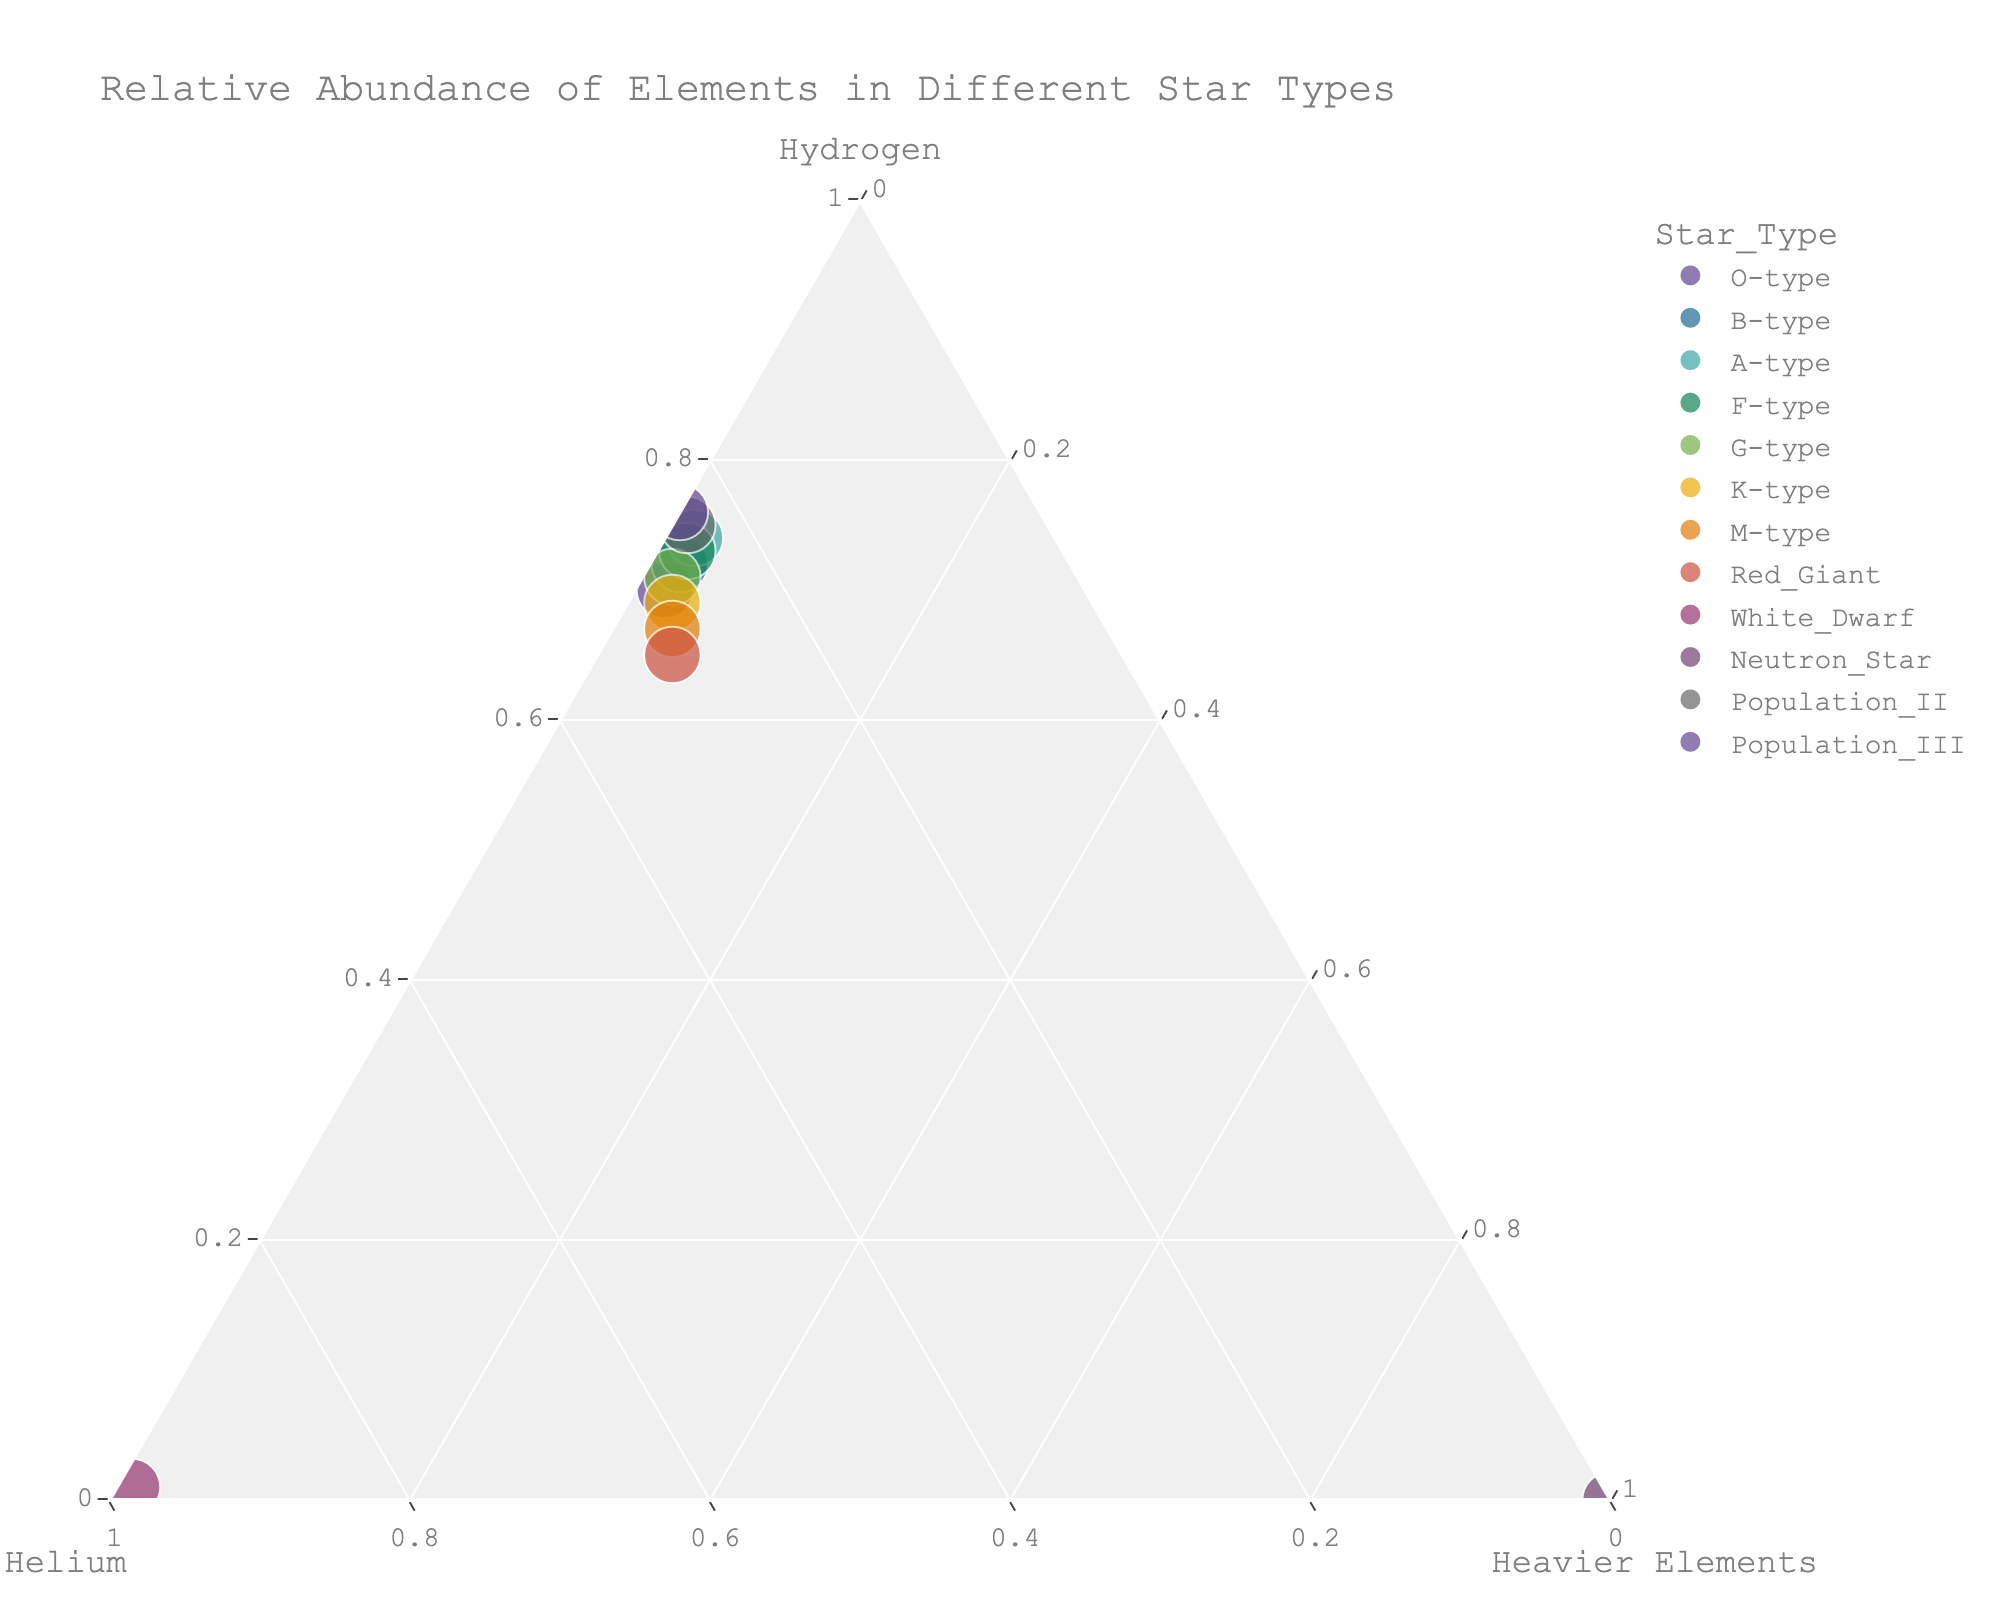What star type has the highest concentration of helium? Look at the figure and identify the star type with the greatest proportion of helium in the ternary plot. Here, the White Dwarf has 0.98 or 98% helium, which is the highest.
Answer: White Dwarf Which star type has the most balanced composition of hydrogen, helium, and heavier elements? Examine the position of the points on the ternary plot. The Red Giant appears closest to the center, indicating a relatively balanced mixture of hydrogen, helium, and heavier elements.
Answer: Red Giant What is the percentage of heavier elements in Neutron Stars? Locate the point representing Neutron Stars in the ternary plot, which is at the extreme corner for heavier elements, indicating 100% composition.
Answer: 100% How does the helium content of O-type stars compare to G-type stars? Observe the positions of O-type and G-type stars in the ternary plot. O-type stars have 28% helium, while G-type stars have 27% helium, so O-type stars have slightly more.
Answer: O-type has more If you sum the helium and heavier elements in Population III stars, what proportion of the star is hydrogen? Population III stars have 24% helium and 0% heavier elements. Summing these gives 24%, so the remaining 76% is hydrogen.
Answer: 76% Which star type lies closest to the hydrogen vertex in the ternary plot? Identify the star type closest to the vertex representing 100% hydrogen. Population III stars appear to be nearest.
Answer: Population III Is there any star type with zero hydrogen content? Locate points on the plot that do not project any value towards the hydrogen axis. The Neutron Star has 0% hydrogen.
Answer: Yes, Neutron Star What star type has the second highest percentage of heavier elements? Compare the positions of the points near the heavier elements axis. The Red Giant, with 5% heavier elements, is second to Neutron Stars.
Answer: Red Giant 